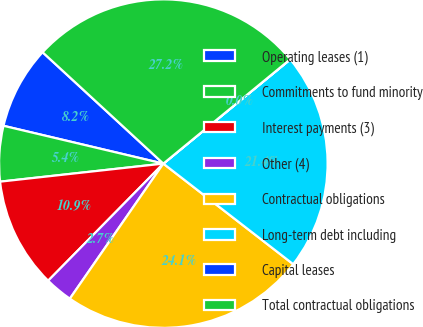<chart> <loc_0><loc_0><loc_500><loc_500><pie_chart><fcel>Operating leases (1)<fcel>Commitments to fund minority<fcel>Interest payments (3)<fcel>Other (4)<fcel>Contractual obligations<fcel>Long-term debt including<fcel>Capital leases<fcel>Total contractual obligations<nl><fcel>8.16%<fcel>5.45%<fcel>10.88%<fcel>2.73%<fcel>24.15%<fcel>21.43%<fcel>0.01%<fcel>27.19%<nl></chart> 